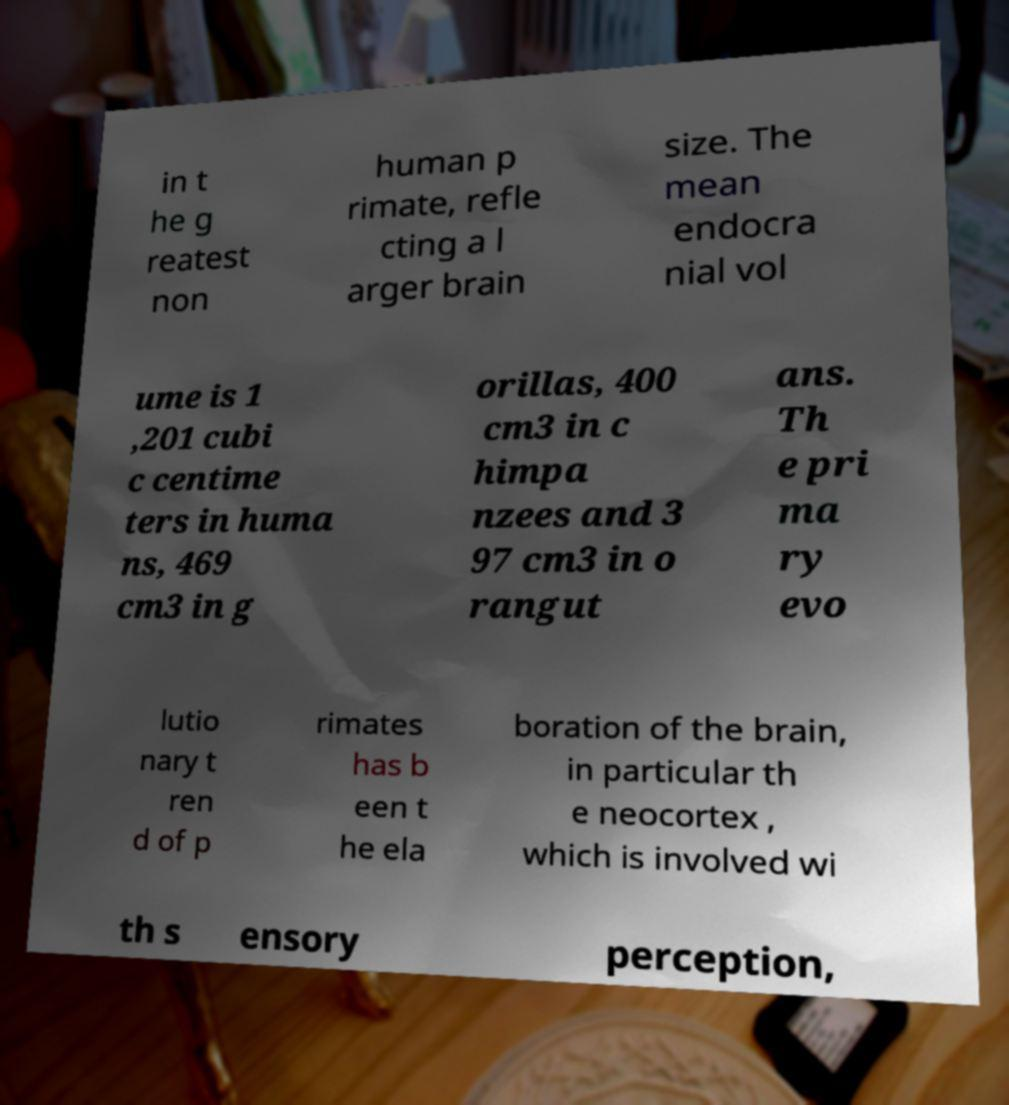What messages or text are displayed in this image? I need them in a readable, typed format. in t he g reatest non human p rimate, refle cting a l arger brain size. The mean endocra nial vol ume is 1 ,201 cubi c centime ters in huma ns, 469 cm3 in g orillas, 400 cm3 in c himpa nzees and 3 97 cm3 in o rangut ans. Th e pri ma ry evo lutio nary t ren d of p rimates has b een t he ela boration of the brain, in particular th e neocortex , which is involved wi th s ensory perception, 